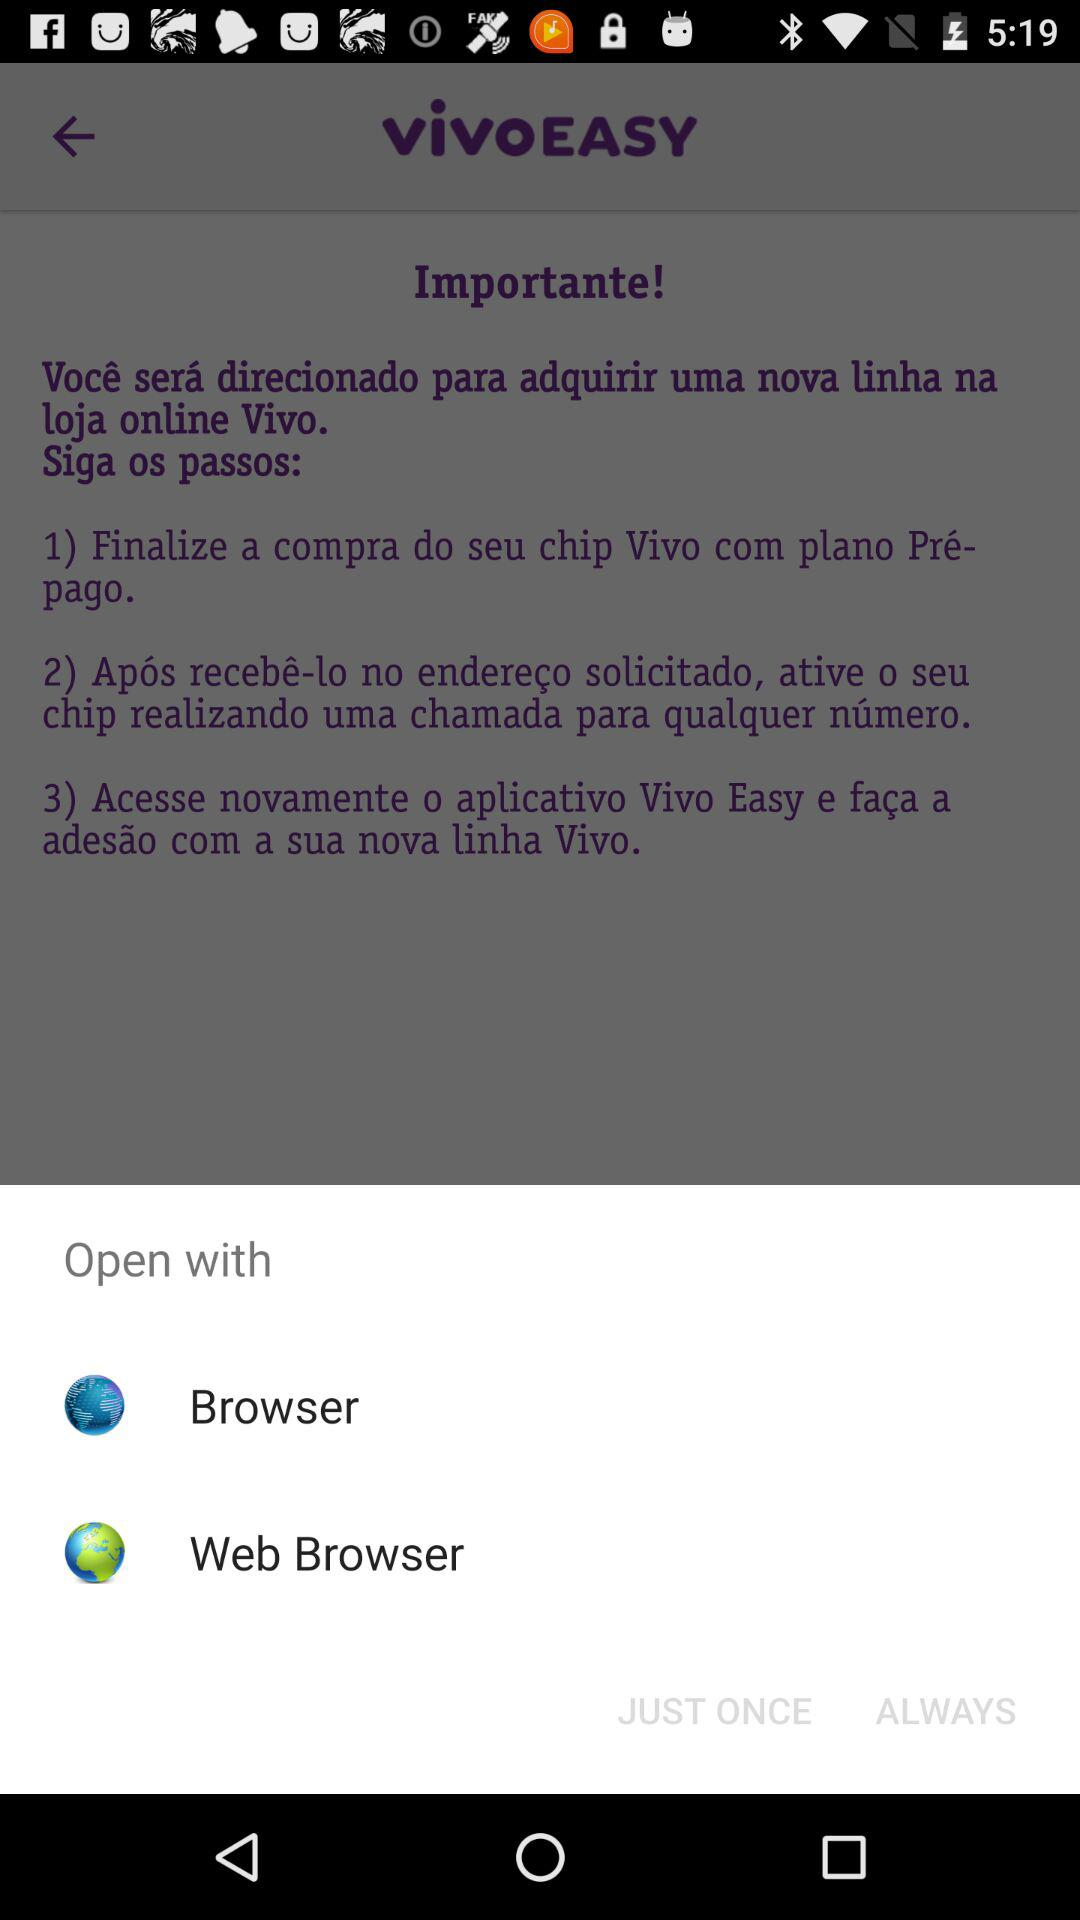How many options are available in the Open with menu?
Answer the question using a single word or phrase. 2 